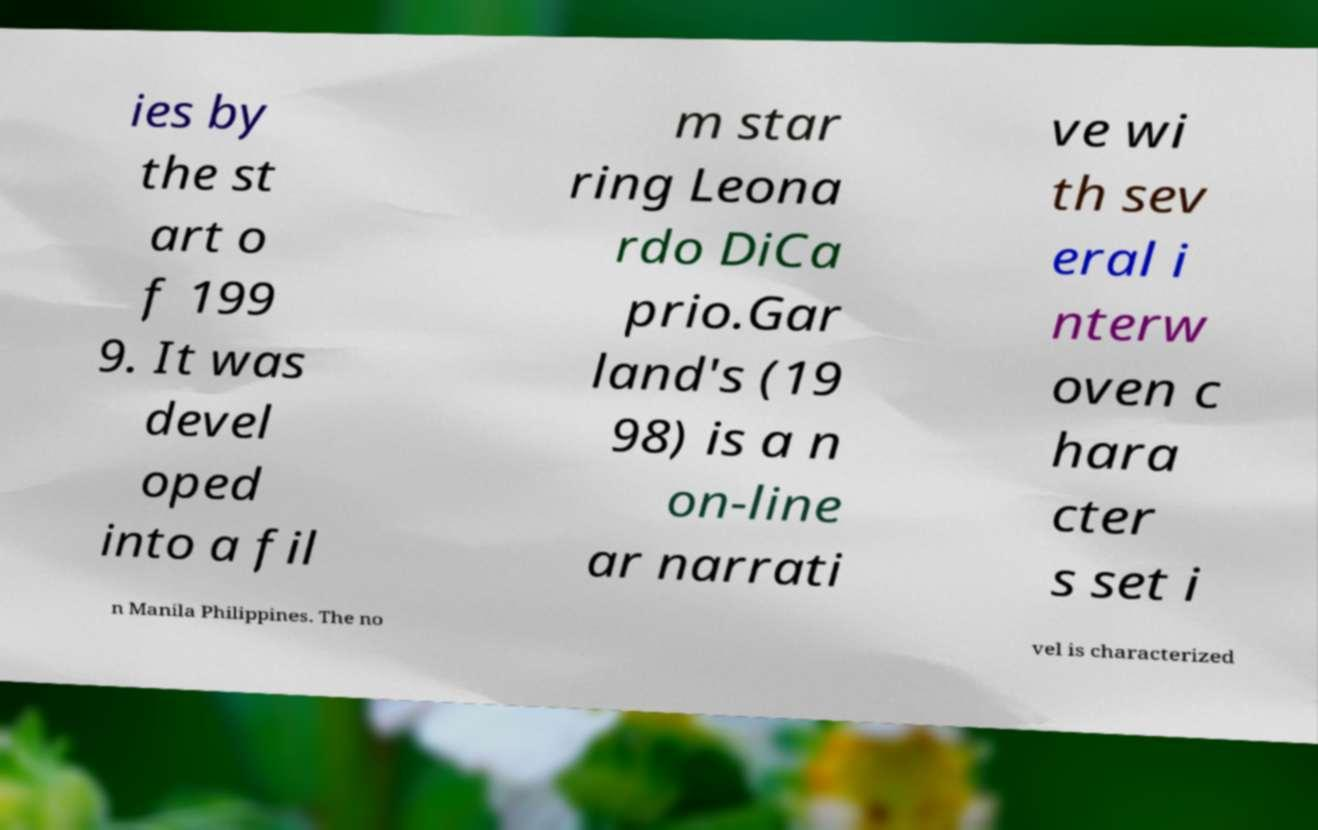I need the written content from this picture converted into text. Can you do that? ies by the st art o f 199 9. It was devel oped into a fil m star ring Leona rdo DiCa prio.Gar land's (19 98) is a n on-line ar narrati ve wi th sev eral i nterw oven c hara cter s set i n Manila Philippines. The no vel is characterized 